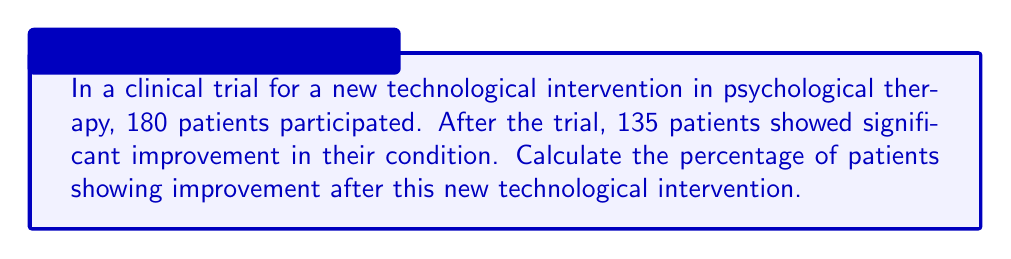Give your solution to this math problem. To calculate the percentage of patients showing improvement, we need to follow these steps:

1. Identify the total number of patients: 180
2. Identify the number of patients showing improvement: 135
3. Use the formula for percentage:

   $$ \text{Percentage} = \frac{\text{Number of patients showing improvement}}{\text{Total number of patients}} \times 100 $$

4. Plug in the values:

   $$ \text{Percentage} = \frac{135}{180} \times 100 $$

5. Simplify the fraction:
   
   $$ \text{Percentage} = \frac{3}{4} \times 100 $$

6. Perform the multiplication:

   $$ \text{Percentage} = 0.75 \times 100 = 75 $$

Therefore, 75% of patients showed improvement after the new technological intervention.
Answer: 75% 